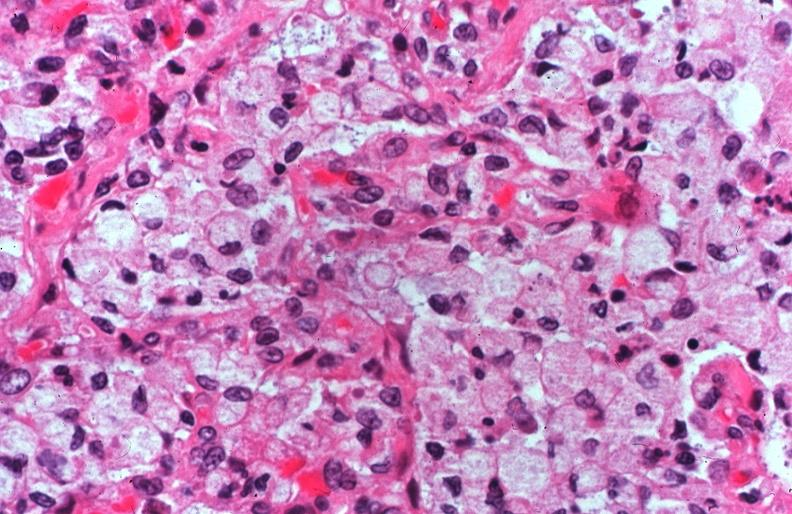what is present?
Answer the question using a single word or phrase. Respiratory 